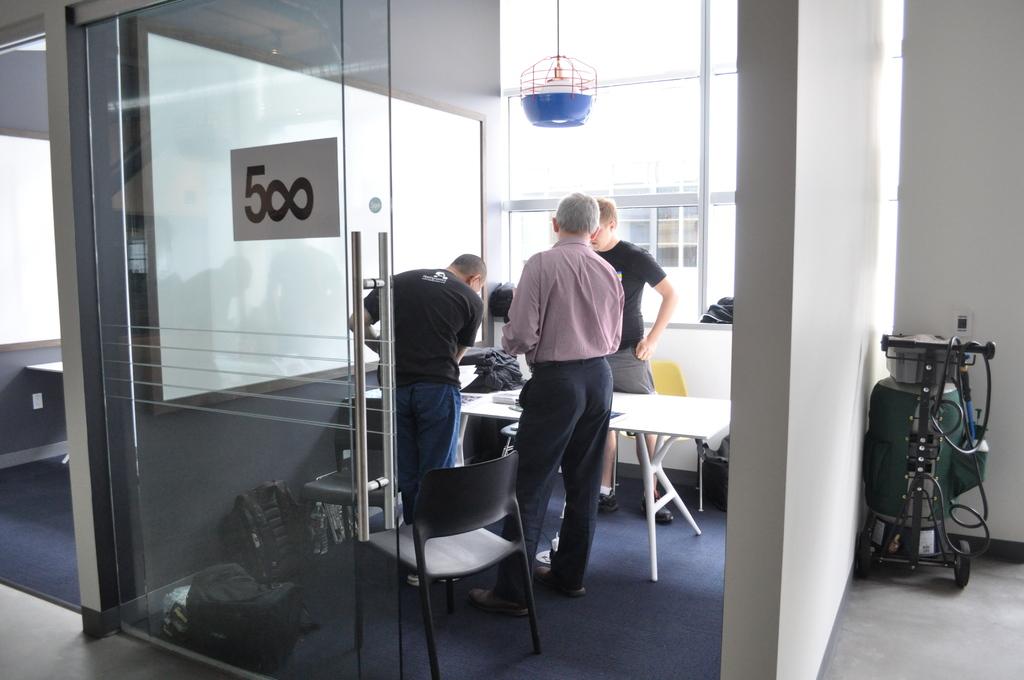What sign is on the door?
Your answer should be compact. 500. What number is written on the glass door?
Provide a succinct answer. 500. 